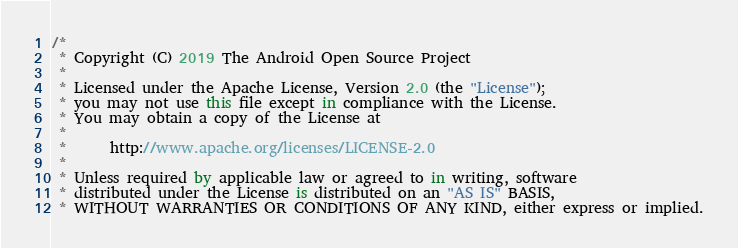Convert code to text. <code><loc_0><loc_0><loc_500><loc_500><_Kotlin_>/*
 * Copyright (C) 2019 The Android Open Source Project
 *
 * Licensed under the Apache License, Version 2.0 (the "License");
 * you may not use this file except in compliance with the License.
 * You may obtain a copy of the License at
 *
 *      http://www.apache.org/licenses/LICENSE-2.0
 *
 * Unless required by applicable law or agreed to in writing, software
 * distributed under the License is distributed on an "AS IS" BASIS,
 * WITHOUT WARRANTIES OR CONDITIONS OF ANY KIND, either express or implied.</code> 